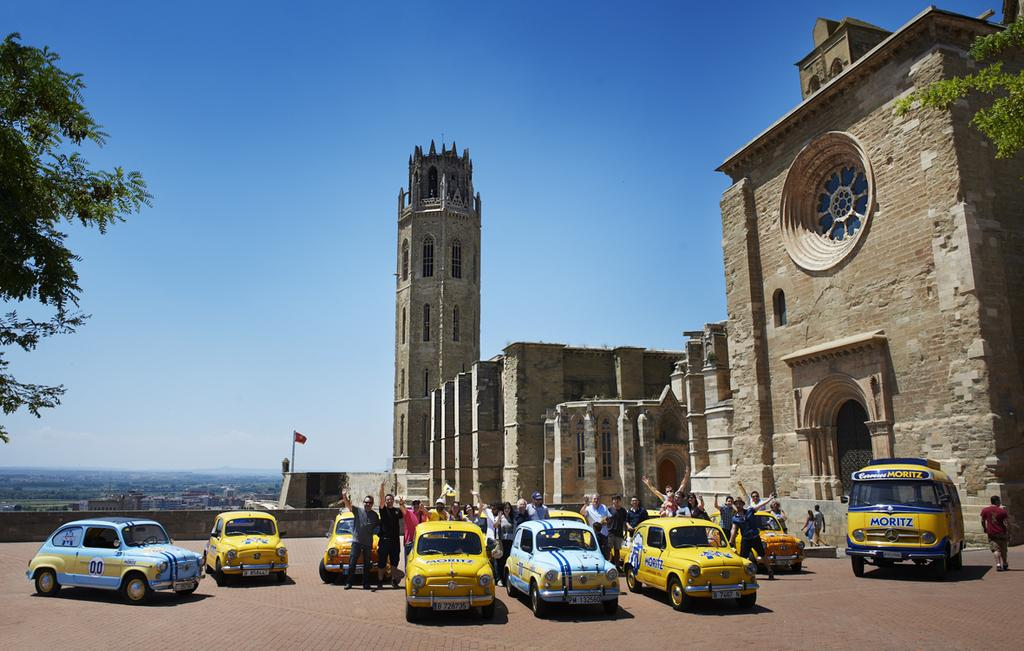<image>
Give a short and clear explanation of the subsequent image. Several vehicles display the word Moritz in blue lettering. 